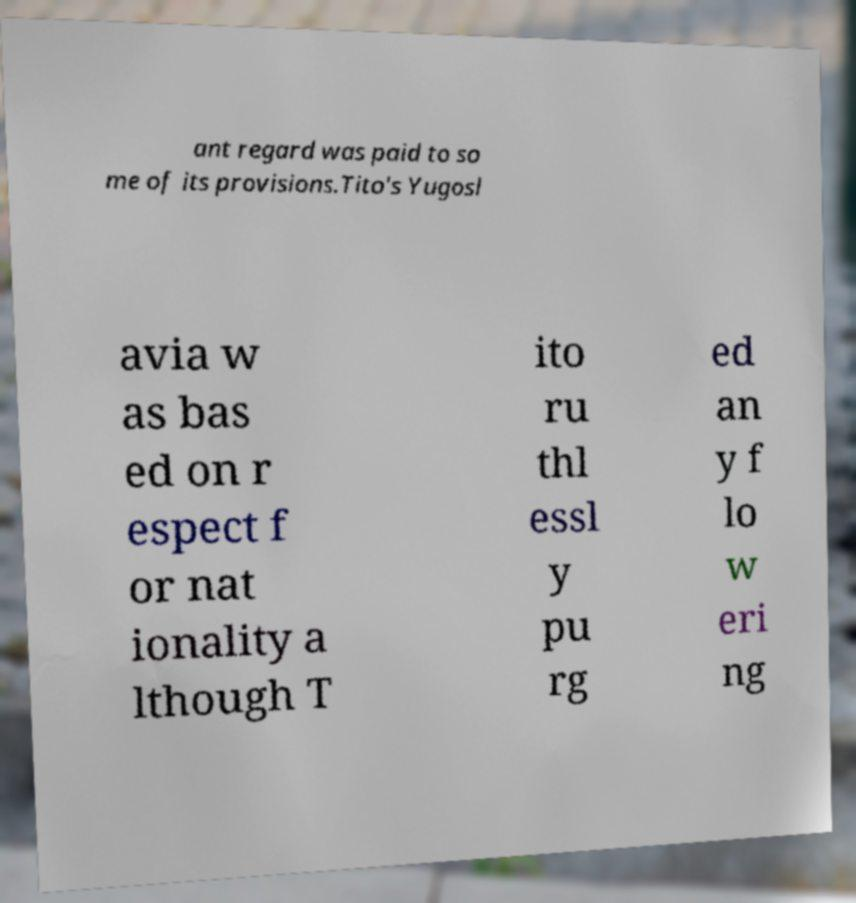I need the written content from this picture converted into text. Can you do that? ant regard was paid to so me of its provisions.Tito's Yugosl avia w as bas ed on r espect f or nat ionality a lthough T ito ru thl essl y pu rg ed an y f lo w eri ng 